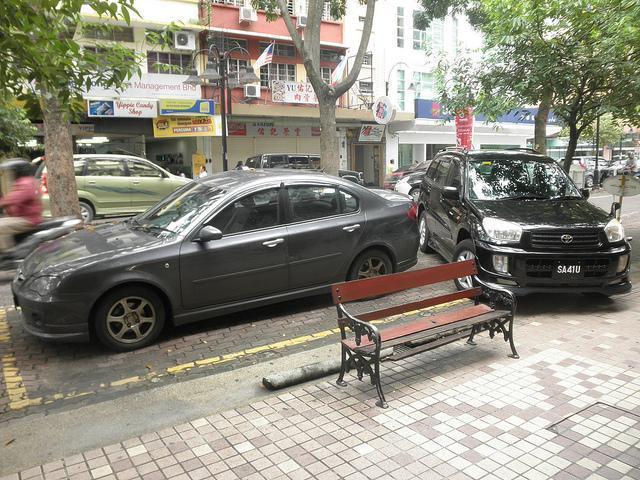Which car violates the law?
Select the correct answer and articulate reasoning with the following format: 'Answer: answer
Rationale: rationale.'
Options: Black car, green car, red car, silver car. Answer: black car.
Rationale: The black car can't park behind the gray one. 